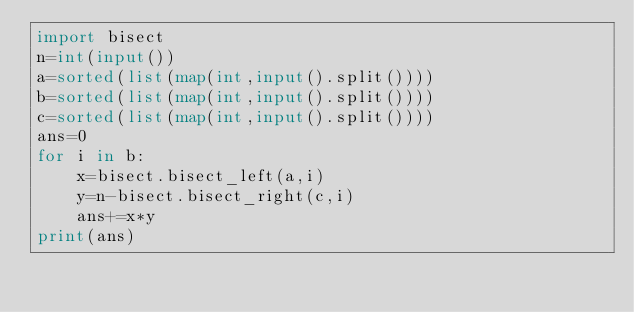<code> <loc_0><loc_0><loc_500><loc_500><_Python_>import bisect
n=int(input())
a=sorted(list(map(int,input().split())))
b=sorted(list(map(int,input().split())))
c=sorted(list(map(int,input().split())))
ans=0
for i in b:
    x=bisect.bisect_left(a,i)
    y=n-bisect.bisect_right(c,i)
    ans+=x*y
print(ans)</code> 